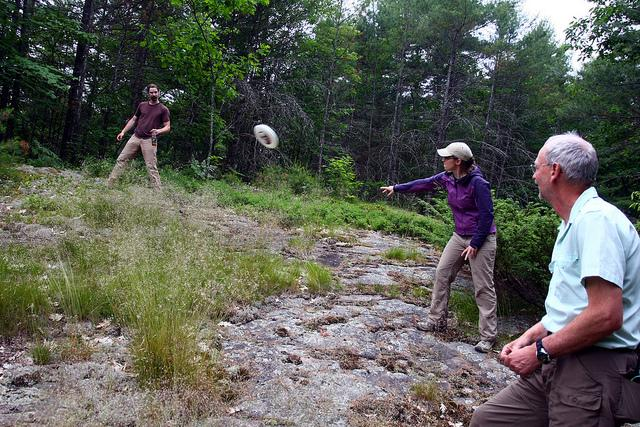Who is standing at a higher level on the rock?

Choices:
A) blue shirt
B) brown shirt
C) purple shirt
D) white frisbee brown shirt 